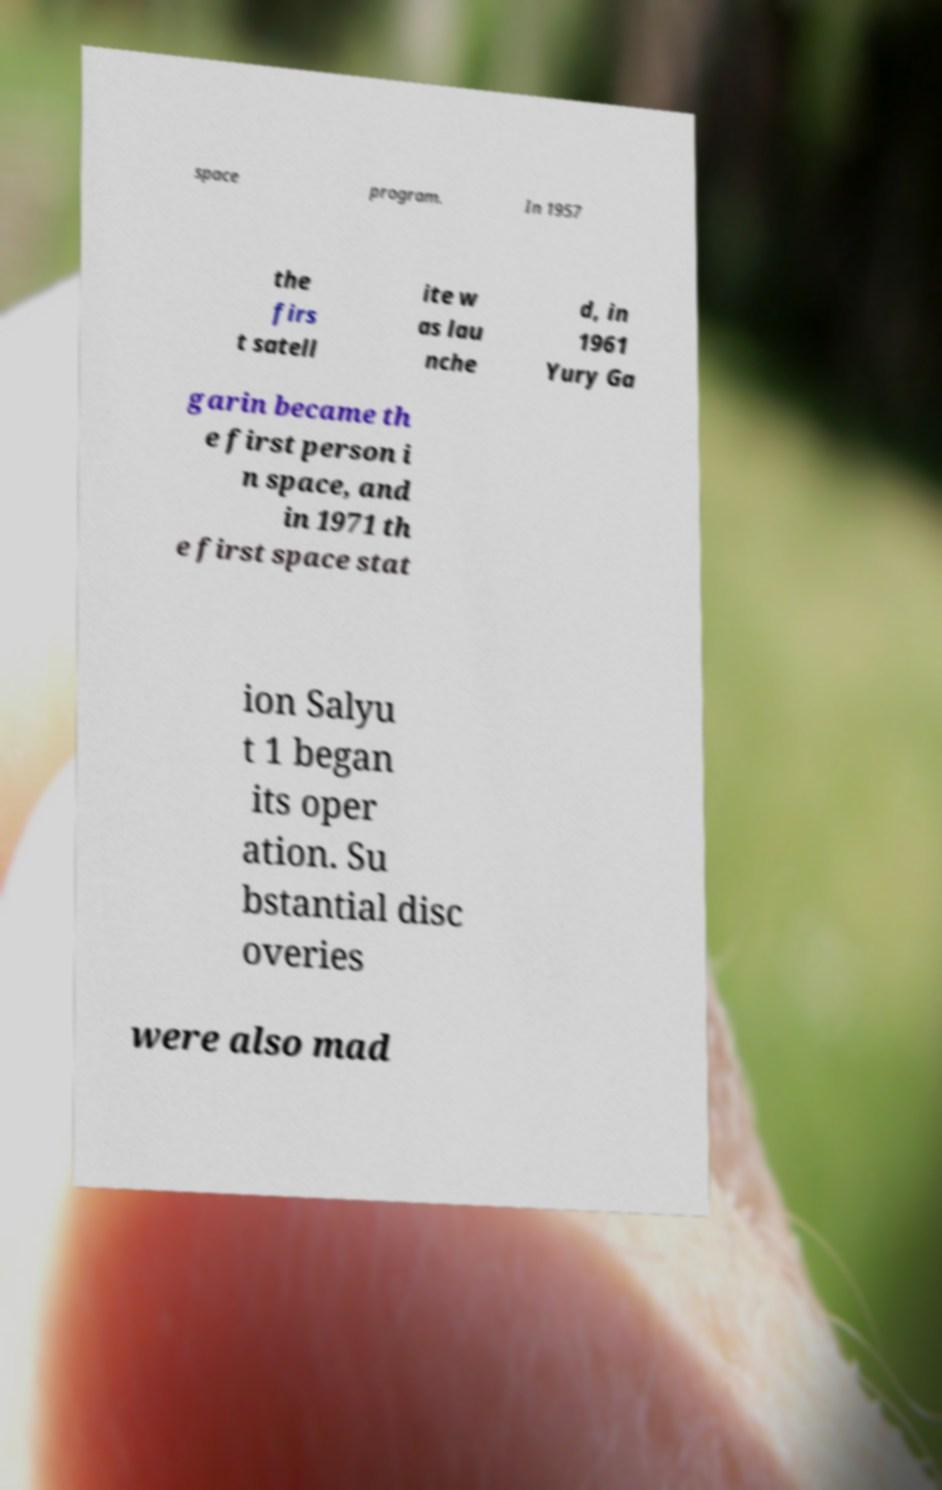For documentation purposes, I need the text within this image transcribed. Could you provide that? space program. In 1957 the firs t satell ite w as lau nche d, in 1961 Yury Ga garin became th e first person i n space, and in 1971 th e first space stat ion Salyu t 1 began its oper ation. Su bstantial disc overies were also mad 